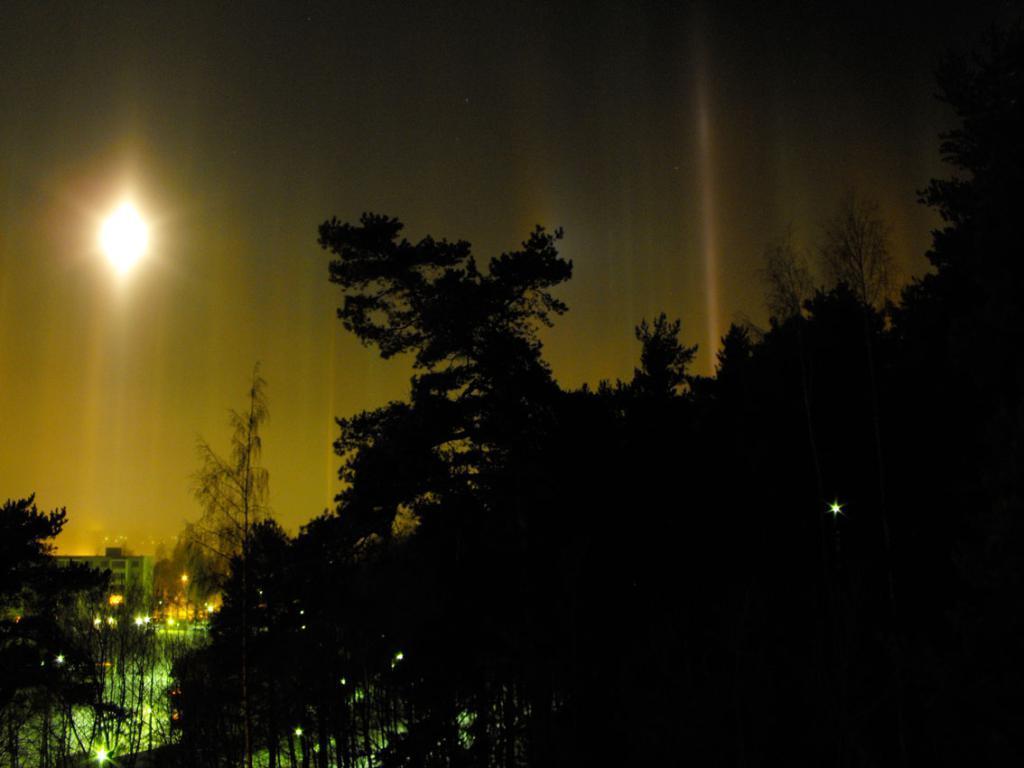Can you describe this image briefly? There are trees in the right corner and there is a building and few lights in the left corner. 